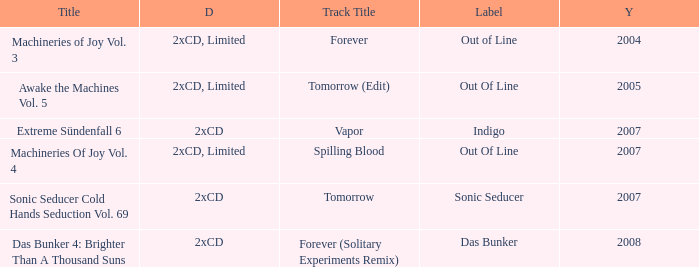Which track title has a year lesser thsn 2005? Forever. 